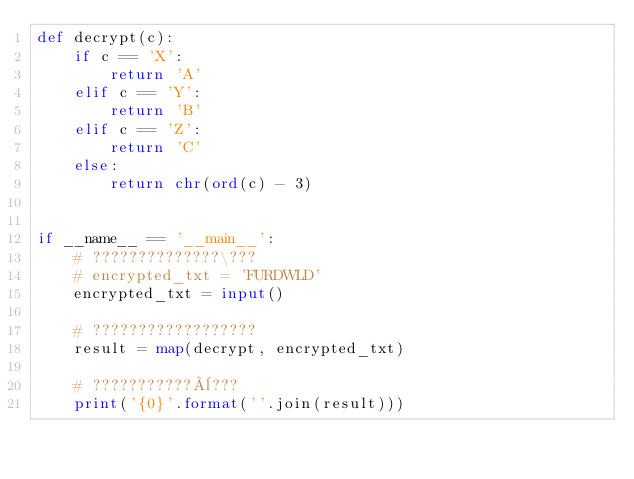Convert code to text. <code><loc_0><loc_0><loc_500><loc_500><_Python_>def decrypt(c):
    if c == 'X':
        return 'A'
    elif c == 'Y':
        return 'B'
    elif c == 'Z':
        return 'C'
    else:
        return chr(ord(c) - 3)


if __name__ == '__main__':
    # ??????????????\???
    # encrypted_txt = 'FURDWLD'
    encrypted_txt = input()

    # ??????????????????
    result = map(decrypt, encrypted_txt)

    # ???????????¨???
    print('{0}'.format(''.join(result)))</code> 